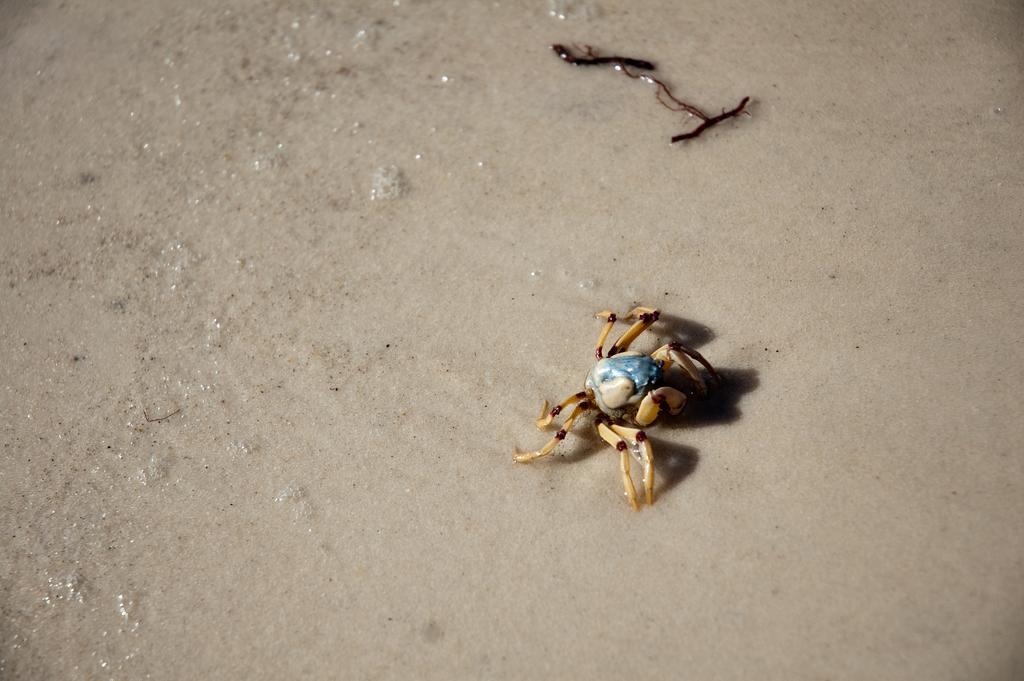Describe this image in one or two sentences. In the picture we can see a wet sand surface on it we can see a crab which is blue in color with its legs yellow in color and some part blue in color and beside it we can see some twig on the surface. 